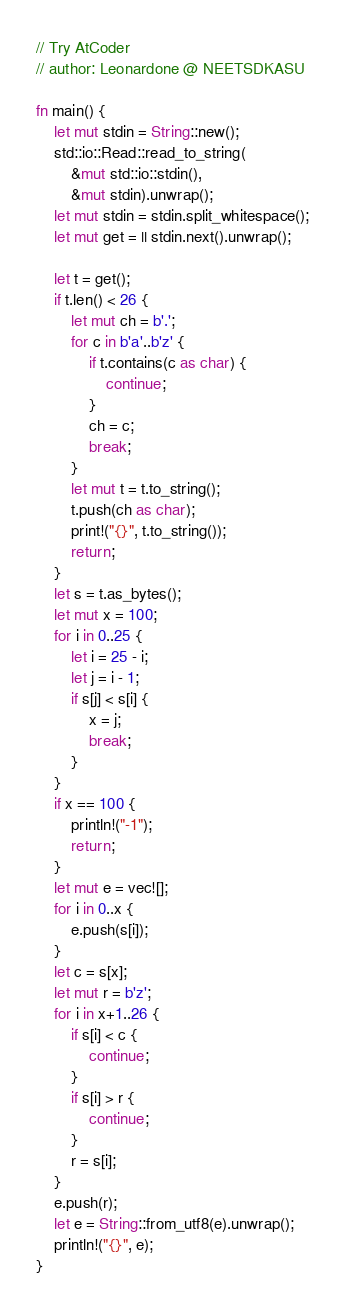Convert code to text. <code><loc_0><loc_0><loc_500><loc_500><_Rust_>// Try AtCoder
// author: Leonardone @ NEETSDKASU

fn main() {
    let mut stdin = String::new();
    std::io::Read::read_to_string(
        &mut std::io::stdin(),
        &mut stdin).unwrap();
    let mut stdin = stdin.split_whitespace();
    let mut get = || stdin.next().unwrap();
    
    let t = get();
    if t.len() < 26 {
    	let mut ch = b'.';
    	for c in b'a'..b'z' {
        	if t.contains(c as char) {
            	continue;
            }
        	ch = c;
            break;
        }
        let mut t = t.to_string();
        t.push(ch as char);
        print!("{}", t.to_string());
        return;
    }
    let s = t.as_bytes();
    let mut x = 100;
    for i in 0..25 {
    	let i = 25 - i;
        let j = i - 1;
        if s[j] < s[i] {
        	x = j;
            break;
        }
    }
    if x == 100 {
    	println!("-1");
        return;
    }
    let mut e = vec![];
    for i in 0..x {
    	e.push(s[i]);
    }
    let c = s[x];
    let mut r = b'z';
    for i in x+1..26 {
    	if s[i] < c {
        	continue;
        }
        if s[i] > r {
        	continue;
        }
        r = s[i];
    }
    e.push(r);
    let e = String::from_utf8(e).unwrap();
    println!("{}", e);
}</code> 